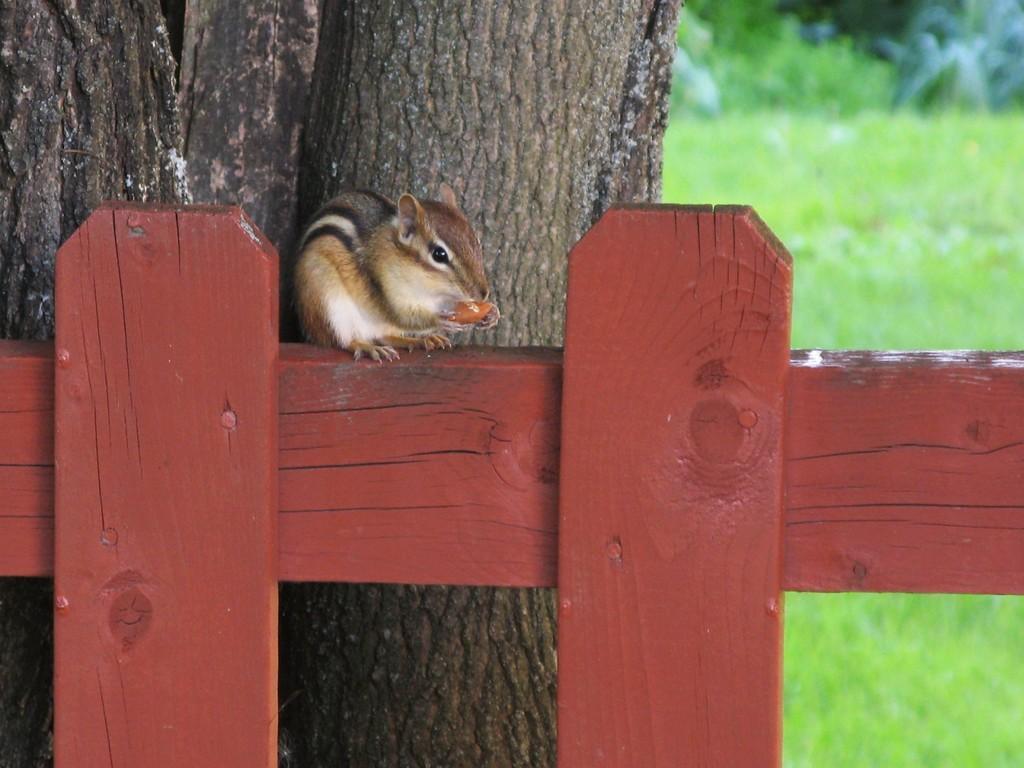Please provide a concise description of this image. In this image I can see the wooden object and on it I can see a squirrel which is cream, brown and black in color is holding a orange colored object. In the background I can see few trees and some grass. 